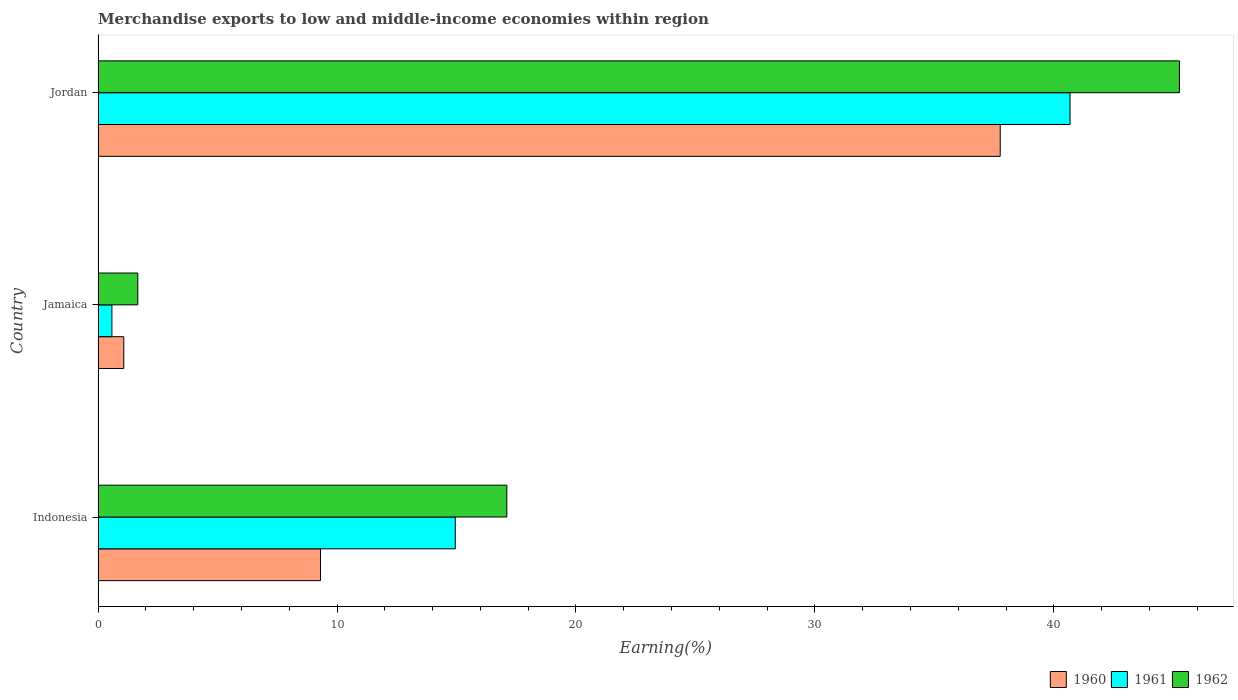How many different coloured bars are there?
Give a very brief answer. 3. Are the number of bars on each tick of the Y-axis equal?
Make the answer very short. Yes. How many bars are there on the 3rd tick from the bottom?
Keep it short and to the point. 3. What is the label of the 3rd group of bars from the top?
Offer a terse response. Indonesia. What is the percentage of amount earned from merchandise exports in 1960 in Jordan?
Keep it short and to the point. 37.76. Across all countries, what is the maximum percentage of amount earned from merchandise exports in 1960?
Provide a succinct answer. 37.76. Across all countries, what is the minimum percentage of amount earned from merchandise exports in 1961?
Offer a terse response. 0.58. In which country was the percentage of amount earned from merchandise exports in 1960 maximum?
Give a very brief answer. Jordan. In which country was the percentage of amount earned from merchandise exports in 1962 minimum?
Your response must be concise. Jamaica. What is the total percentage of amount earned from merchandise exports in 1961 in the graph?
Offer a very short reply. 56.2. What is the difference between the percentage of amount earned from merchandise exports in 1961 in Jamaica and that in Jordan?
Provide a short and direct response. -40.1. What is the difference between the percentage of amount earned from merchandise exports in 1962 in Jamaica and the percentage of amount earned from merchandise exports in 1960 in Indonesia?
Provide a short and direct response. -7.65. What is the average percentage of amount earned from merchandise exports in 1961 per country?
Provide a succinct answer. 18.73. What is the difference between the percentage of amount earned from merchandise exports in 1962 and percentage of amount earned from merchandise exports in 1960 in Jordan?
Make the answer very short. 7.5. In how many countries, is the percentage of amount earned from merchandise exports in 1961 greater than 18 %?
Give a very brief answer. 1. What is the ratio of the percentage of amount earned from merchandise exports in 1960 in Jamaica to that in Jordan?
Offer a terse response. 0.03. Is the difference between the percentage of amount earned from merchandise exports in 1962 in Indonesia and Jordan greater than the difference between the percentage of amount earned from merchandise exports in 1960 in Indonesia and Jordan?
Give a very brief answer. Yes. What is the difference between the highest and the second highest percentage of amount earned from merchandise exports in 1960?
Offer a very short reply. 28.45. What is the difference between the highest and the lowest percentage of amount earned from merchandise exports in 1961?
Make the answer very short. 40.1. In how many countries, is the percentage of amount earned from merchandise exports in 1962 greater than the average percentage of amount earned from merchandise exports in 1962 taken over all countries?
Your answer should be very brief. 1. Is the sum of the percentage of amount earned from merchandise exports in 1961 in Indonesia and Jamaica greater than the maximum percentage of amount earned from merchandise exports in 1960 across all countries?
Ensure brevity in your answer.  No. What does the 3rd bar from the bottom in Indonesia represents?
Give a very brief answer. 1962. Is it the case that in every country, the sum of the percentage of amount earned from merchandise exports in 1961 and percentage of amount earned from merchandise exports in 1962 is greater than the percentage of amount earned from merchandise exports in 1960?
Keep it short and to the point. Yes. Are all the bars in the graph horizontal?
Offer a terse response. Yes. How many countries are there in the graph?
Your answer should be very brief. 3. Are the values on the major ticks of X-axis written in scientific E-notation?
Offer a very short reply. No. Does the graph contain grids?
Your answer should be very brief. No. Where does the legend appear in the graph?
Ensure brevity in your answer.  Bottom right. What is the title of the graph?
Your response must be concise. Merchandise exports to low and middle-income economies within region. What is the label or title of the X-axis?
Make the answer very short. Earning(%). What is the label or title of the Y-axis?
Ensure brevity in your answer.  Country. What is the Earning(%) in 1960 in Indonesia?
Give a very brief answer. 9.31. What is the Earning(%) of 1961 in Indonesia?
Your answer should be very brief. 14.95. What is the Earning(%) of 1962 in Indonesia?
Provide a short and direct response. 17.11. What is the Earning(%) of 1960 in Jamaica?
Your answer should be compact. 1.07. What is the Earning(%) of 1961 in Jamaica?
Ensure brevity in your answer.  0.58. What is the Earning(%) in 1962 in Jamaica?
Offer a terse response. 1.66. What is the Earning(%) in 1960 in Jordan?
Give a very brief answer. 37.76. What is the Earning(%) of 1961 in Jordan?
Keep it short and to the point. 40.68. What is the Earning(%) in 1962 in Jordan?
Provide a succinct answer. 45.26. Across all countries, what is the maximum Earning(%) of 1960?
Keep it short and to the point. 37.76. Across all countries, what is the maximum Earning(%) in 1961?
Your answer should be compact. 40.68. Across all countries, what is the maximum Earning(%) in 1962?
Ensure brevity in your answer.  45.26. Across all countries, what is the minimum Earning(%) in 1960?
Offer a terse response. 1.07. Across all countries, what is the minimum Earning(%) in 1961?
Make the answer very short. 0.58. Across all countries, what is the minimum Earning(%) in 1962?
Keep it short and to the point. 1.66. What is the total Earning(%) in 1960 in the graph?
Offer a very short reply. 48.13. What is the total Earning(%) of 1961 in the graph?
Give a very brief answer. 56.2. What is the total Earning(%) of 1962 in the graph?
Offer a terse response. 64.02. What is the difference between the Earning(%) of 1960 in Indonesia and that in Jamaica?
Provide a short and direct response. 8.23. What is the difference between the Earning(%) of 1961 in Indonesia and that in Jamaica?
Keep it short and to the point. 14.37. What is the difference between the Earning(%) in 1962 in Indonesia and that in Jamaica?
Provide a short and direct response. 15.45. What is the difference between the Earning(%) in 1960 in Indonesia and that in Jordan?
Provide a succinct answer. -28.45. What is the difference between the Earning(%) of 1961 in Indonesia and that in Jordan?
Ensure brevity in your answer.  -25.73. What is the difference between the Earning(%) of 1962 in Indonesia and that in Jordan?
Your response must be concise. -28.15. What is the difference between the Earning(%) in 1960 in Jamaica and that in Jordan?
Give a very brief answer. -36.68. What is the difference between the Earning(%) of 1961 in Jamaica and that in Jordan?
Offer a terse response. -40.1. What is the difference between the Earning(%) of 1962 in Jamaica and that in Jordan?
Make the answer very short. -43.6. What is the difference between the Earning(%) in 1960 in Indonesia and the Earning(%) in 1961 in Jamaica?
Provide a short and direct response. 8.73. What is the difference between the Earning(%) of 1960 in Indonesia and the Earning(%) of 1962 in Jamaica?
Make the answer very short. 7.65. What is the difference between the Earning(%) in 1961 in Indonesia and the Earning(%) in 1962 in Jamaica?
Your answer should be compact. 13.29. What is the difference between the Earning(%) in 1960 in Indonesia and the Earning(%) in 1961 in Jordan?
Your answer should be compact. -31.37. What is the difference between the Earning(%) of 1960 in Indonesia and the Earning(%) of 1962 in Jordan?
Ensure brevity in your answer.  -35.95. What is the difference between the Earning(%) in 1961 in Indonesia and the Earning(%) in 1962 in Jordan?
Make the answer very short. -30.31. What is the difference between the Earning(%) in 1960 in Jamaica and the Earning(%) in 1961 in Jordan?
Give a very brief answer. -39.6. What is the difference between the Earning(%) in 1960 in Jamaica and the Earning(%) in 1962 in Jordan?
Make the answer very short. -44.18. What is the difference between the Earning(%) in 1961 in Jamaica and the Earning(%) in 1962 in Jordan?
Ensure brevity in your answer.  -44.68. What is the average Earning(%) in 1960 per country?
Provide a short and direct response. 16.04. What is the average Earning(%) in 1961 per country?
Offer a very short reply. 18.73. What is the average Earning(%) in 1962 per country?
Ensure brevity in your answer.  21.34. What is the difference between the Earning(%) of 1960 and Earning(%) of 1961 in Indonesia?
Give a very brief answer. -5.64. What is the difference between the Earning(%) of 1960 and Earning(%) of 1962 in Indonesia?
Give a very brief answer. -7.8. What is the difference between the Earning(%) of 1961 and Earning(%) of 1962 in Indonesia?
Keep it short and to the point. -2.16. What is the difference between the Earning(%) of 1960 and Earning(%) of 1961 in Jamaica?
Keep it short and to the point. 0.5. What is the difference between the Earning(%) of 1960 and Earning(%) of 1962 in Jamaica?
Give a very brief answer. -0.59. What is the difference between the Earning(%) of 1961 and Earning(%) of 1962 in Jamaica?
Provide a succinct answer. -1.08. What is the difference between the Earning(%) in 1960 and Earning(%) in 1961 in Jordan?
Give a very brief answer. -2.92. What is the difference between the Earning(%) in 1960 and Earning(%) in 1962 in Jordan?
Ensure brevity in your answer.  -7.5. What is the difference between the Earning(%) of 1961 and Earning(%) of 1962 in Jordan?
Your answer should be compact. -4.58. What is the ratio of the Earning(%) in 1960 in Indonesia to that in Jamaica?
Offer a terse response. 8.67. What is the ratio of the Earning(%) of 1961 in Indonesia to that in Jamaica?
Ensure brevity in your answer.  25.91. What is the ratio of the Earning(%) of 1962 in Indonesia to that in Jamaica?
Your response must be concise. 10.3. What is the ratio of the Earning(%) of 1960 in Indonesia to that in Jordan?
Your answer should be compact. 0.25. What is the ratio of the Earning(%) of 1961 in Indonesia to that in Jordan?
Your answer should be very brief. 0.37. What is the ratio of the Earning(%) of 1962 in Indonesia to that in Jordan?
Your response must be concise. 0.38. What is the ratio of the Earning(%) in 1960 in Jamaica to that in Jordan?
Your answer should be very brief. 0.03. What is the ratio of the Earning(%) in 1961 in Jamaica to that in Jordan?
Ensure brevity in your answer.  0.01. What is the ratio of the Earning(%) of 1962 in Jamaica to that in Jordan?
Your answer should be very brief. 0.04. What is the difference between the highest and the second highest Earning(%) of 1960?
Make the answer very short. 28.45. What is the difference between the highest and the second highest Earning(%) in 1961?
Ensure brevity in your answer.  25.73. What is the difference between the highest and the second highest Earning(%) of 1962?
Offer a very short reply. 28.15. What is the difference between the highest and the lowest Earning(%) in 1960?
Make the answer very short. 36.68. What is the difference between the highest and the lowest Earning(%) in 1961?
Offer a very short reply. 40.1. What is the difference between the highest and the lowest Earning(%) of 1962?
Offer a very short reply. 43.6. 